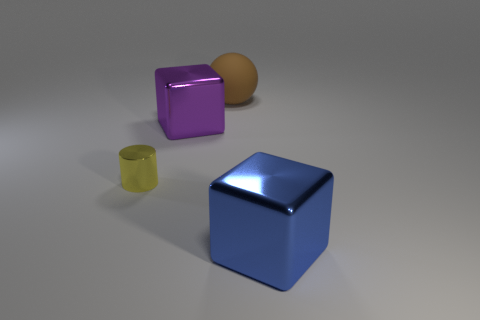Is there any other thing that has the same size as the yellow shiny thing?
Offer a very short reply. No. Is there a brown thing that is on the left side of the shiny thing that is left of the shiny cube to the left of the blue shiny object?
Your response must be concise. No. The large purple thing that is the same material as the cylinder is what shape?
Your answer should be compact. Cube. Are there any other things that have the same shape as the big rubber thing?
Ensure brevity in your answer.  No. The large rubber thing has what shape?
Your answer should be compact. Sphere. There is a object that is in front of the tiny thing; does it have the same shape as the purple shiny object?
Offer a terse response. Yes. Is the number of blue cubes that are to the left of the brown object greater than the number of purple things that are to the left of the yellow metallic object?
Your answer should be very brief. No. How many other objects are the same size as the brown matte sphere?
Make the answer very short. 2. Does the large blue metal object have the same shape as the big purple thing behind the big blue thing?
Keep it short and to the point. Yes. How many shiny objects are either large purple things or yellow spheres?
Make the answer very short. 1. 